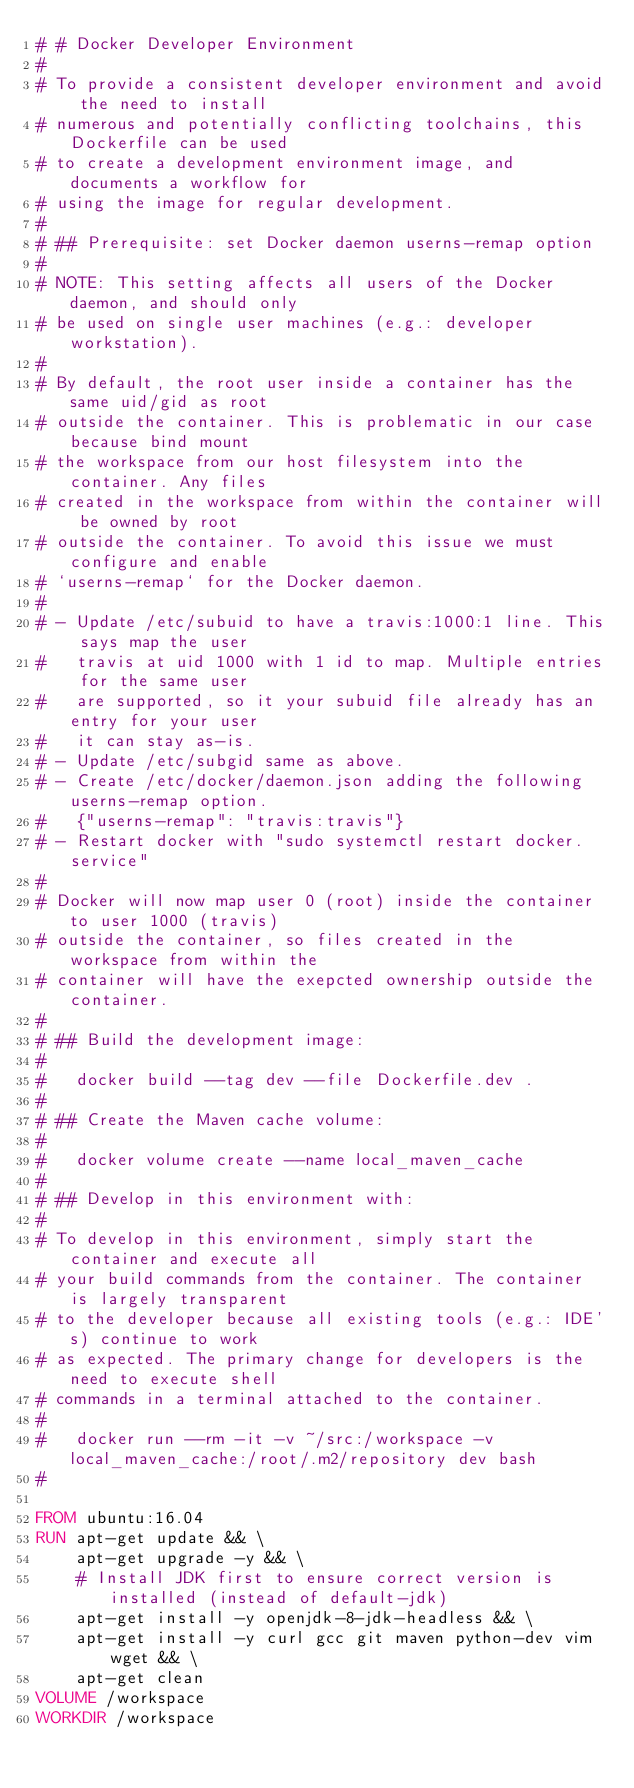<code> <loc_0><loc_0><loc_500><loc_500><_Dockerfile_># # Docker Developer Environment
#
# To provide a consistent developer environment and avoid the need to install
# numerous and potentially conflicting toolchains, this Dockerfile can be used
# to create a development environment image, and documents a workflow for
# using the image for regular development.
#
# ## Prerequisite: set Docker daemon userns-remap option
#
# NOTE: This setting affects all users of the Docker daemon, and should only
# be used on single user machines (e.g.: developer workstation).
#
# By default, the root user inside a container has the same uid/gid as root
# outside the container. This is problematic in our case because bind mount
# the workspace from our host filesystem into the container. Any files
# created in the workspace from within the container will be owned by root
# outside the container. To avoid this issue we must configure and enable
# `userns-remap` for the Docker daemon.
#
# - Update /etc/subuid to have a travis:1000:1 line. This says map the user
#   travis at uid 1000 with 1 id to map. Multiple entries for the same user
#   are supported, so it your subuid file already has an entry for your user
#   it can stay as-is.
# - Update /etc/subgid same as above.
# - Create /etc/docker/daemon.json adding the following userns-remap option.
#   {"userns-remap": "travis:travis"}
# - Restart docker with "sudo systemctl restart docker.service"
#
# Docker will now map user 0 (root) inside the container to user 1000 (travis)
# outside the container, so files created in the workspace from within the
# container will have the exepcted ownership outside the container.
#
# ## Build the development image:
#
#   docker build --tag dev --file Dockerfile.dev . 
#
# ## Create the Maven cache volume:
#
#   docker volume create --name local_maven_cache
#
# ## Develop in this environment with:
#
# To develop in this environment, simply start the container and execute all
# your build commands from the container. The container is largely transparent
# to the developer because all existing tools (e.g.: IDE's) continue to work
# as expected. The primary change for developers is the need to execute shell
# commands in a terminal attached to the container.
#
#   docker run --rm -it -v ~/src:/workspace -v local_maven_cache:/root/.m2/repository dev bash
#

FROM ubuntu:16.04
RUN apt-get update && \
    apt-get upgrade -y && \
    # Install JDK first to ensure correct version is installed (instead of default-jdk)
    apt-get install -y openjdk-8-jdk-headless && \
    apt-get install -y curl gcc git maven python-dev vim wget && \
    apt-get clean
VOLUME /workspace
WORKDIR /workspace
</code> 